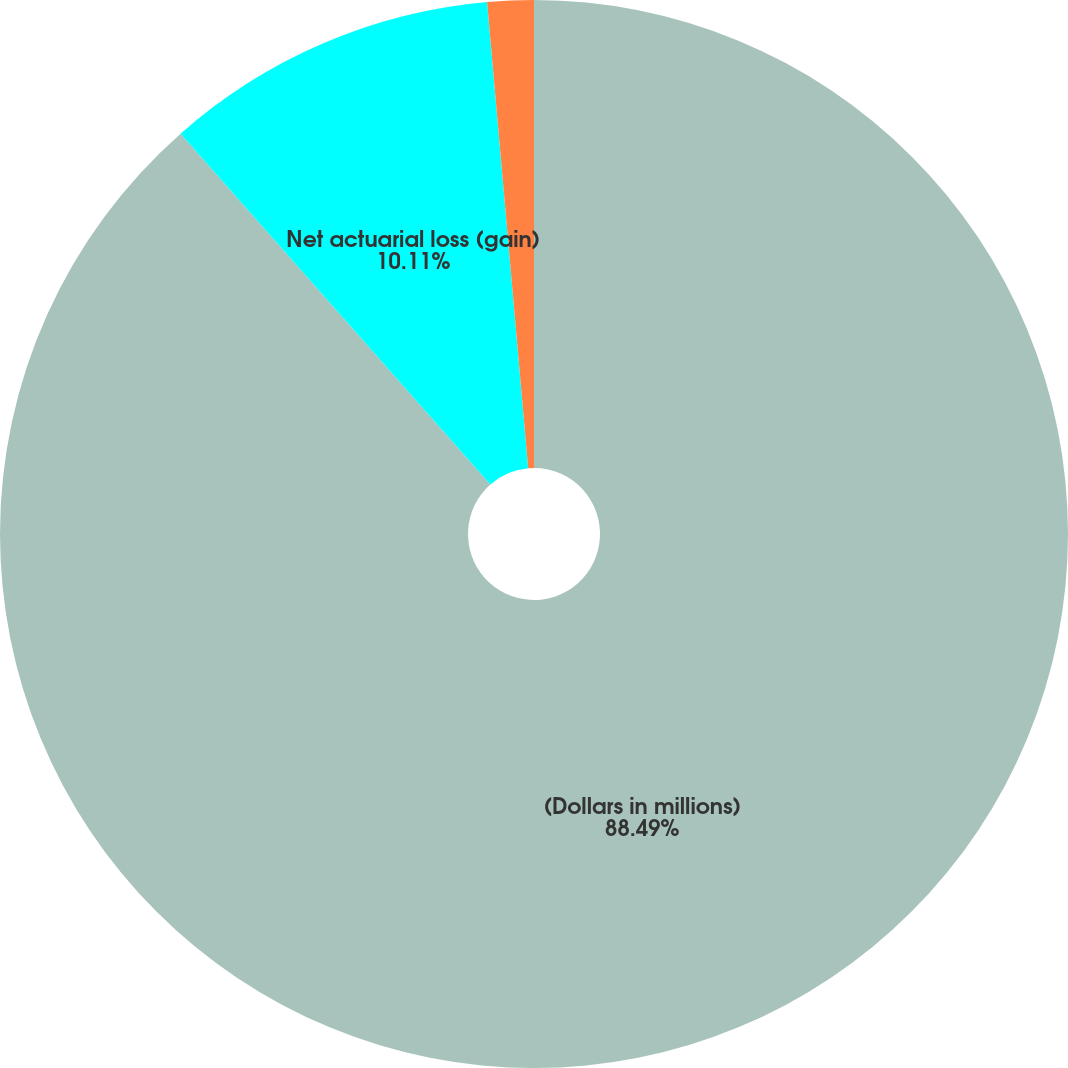Convert chart to OTSL. <chart><loc_0><loc_0><loc_500><loc_500><pie_chart><fcel>(Dollars in millions)<fcel>Net actuarial loss (gain)<fcel>Amounts recognized in<nl><fcel>88.48%<fcel>10.11%<fcel>1.4%<nl></chart> 